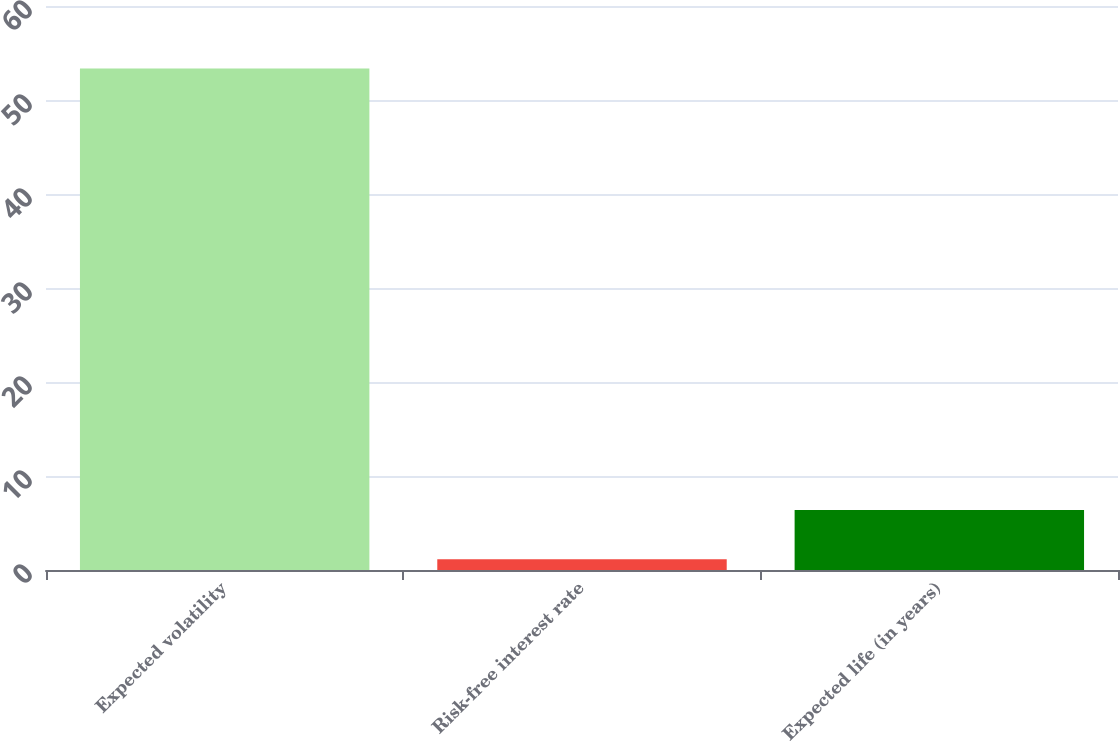<chart> <loc_0><loc_0><loc_500><loc_500><bar_chart><fcel>Expected volatility<fcel>Risk-free interest rate<fcel>Expected life (in years)<nl><fcel>53.36<fcel>1.15<fcel>6.37<nl></chart> 